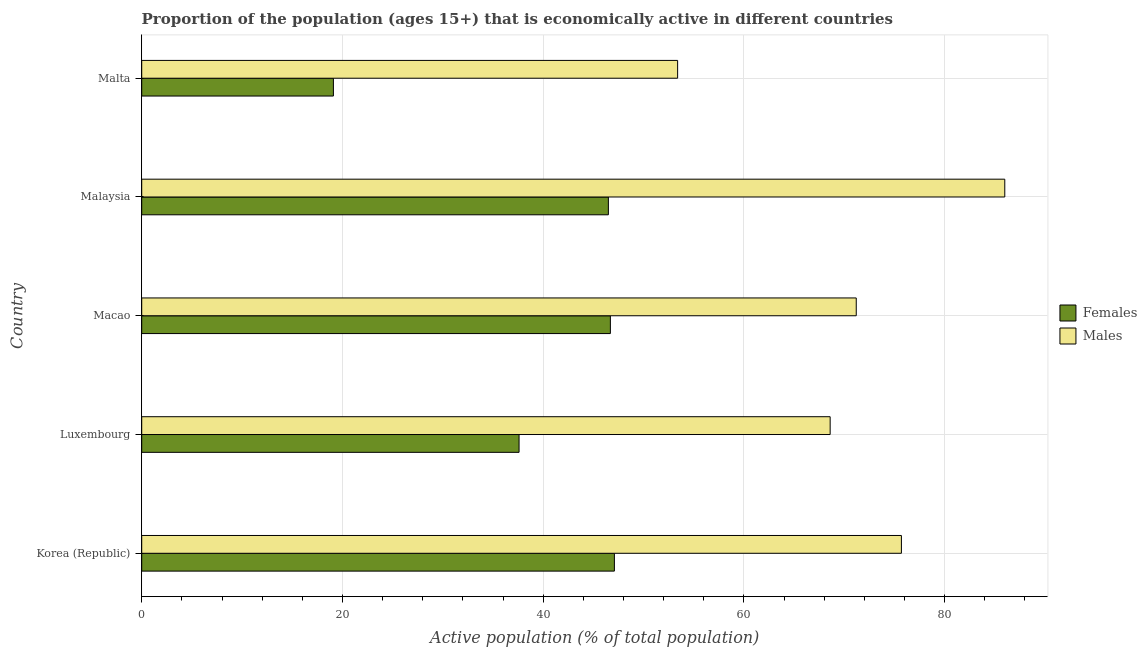Are the number of bars per tick equal to the number of legend labels?
Keep it short and to the point. Yes. How many bars are there on the 1st tick from the top?
Provide a short and direct response. 2. What is the label of the 3rd group of bars from the top?
Ensure brevity in your answer.  Macao. What is the percentage of economically active female population in Luxembourg?
Give a very brief answer. 37.6. Across all countries, what is the maximum percentage of economically active male population?
Offer a very short reply. 86. Across all countries, what is the minimum percentage of economically active female population?
Ensure brevity in your answer.  19.1. In which country was the percentage of economically active male population maximum?
Make the answer very short. Malaysia. In which country was the percentage of economically active male population minimum?
Your response must be concise. Malta. What is the total percentage of economically active male population in the graph?
Your answer should be compact. 354.9. What is the difference between the percentage of economically active female population in Malaysia and that in Malta?
Give a very brief answer. 27.4. What is the difference between the percentage of economically active male population in Malaysia and the percentage of economically active female population in Korea (Republic)?
Offer a very short reply. 38.9. What is the average percentage of economically active male population per country?
Offer a very short reply. 70.98. What is the difference between the percentage of economically active female population and percentage of economically active male population in Malta?
Your response must be concise. -34.3. In how many countries, is the percentage of economically active male population greater than 24 %?
Give a very brief answer. 5. What is the ratio of the percentage of economically active male population in Korea (Republic) to that in Luxembourg?
Offer a terse response. 1.1. What does the 2nd bar from the top in Luxembourg represents?
Offer a very short reply. Females. What does the 2nd bar from the bottom in Malta represents?
Ensure brevity in your answer.  Males. Are the values on the major ticks of X-axis written in scientific E-notation?
Offer a very short reply. No. How are the legend labels stacked?
Keep it short and to the point. Vertical. What is the title of the graph?
Your answer should be compact. Proportion of the population (ages 15+) that is economically active in different countries. Does "Quasi money growth" appear as one of the legend labels in the graph?
Make the answer very short. No. What is the label or title of the X-axis?
Offer a terse response. Active population (% of total population). What is the Active population (% of total population) in Females in Korea (Republic)?
Keep it short and to the point. 47.1. What is the Active population (% of total population) of Males in Korea (Republic)?
Provide a succinct answer. 75.7. What is the Active population (% of total population) in Females in Luxembourg?
Offer a very short reply. 37.6. What is the Active population (% of total population) of Males in Luxembourg?
Offer a very short reply. 68.6. What is the Active population (% of total population) in Females in Macao?
Keep it short and to the point. 46.7. What is the Active population (% of total population) of Males in Macao?
Provide a succinct answer. 71.2. What is the Active population (% of total population) of Females in Malaysia?
Your response must be concise. 46.5. What is the Active population (% of total population) of Males in Malaysia?
Provide a succinct answer. 86. What is the Active population (% of total population) in Females in Malta?
Ensure brevity in your answer.  19.1. What is the Active population (% of total population) in Males in Malta?
Offer a terse response. 53.4. Across all countries, what is the maximum Active population (% of total population) in Females?
Your answer should be very brief. 47.1. Across all countries, what is the minimum Active population (% of total population) of Females?
Your answer should be very brief. 19.1. Across all countries, what is the minimum Active population (% of total population) of Males?
Make the answer very short. 53.4. What is the total Active population (% of total population) in Females in the graph?
Your answer should be very brief. 197. What is the total Active population (% of total population) in Males in the graph?
Your response must be concise. 354.9. What is the difference between the Active population (% of total population) in Females in Korea (Republic) and that in Luxembourg?
Your response must be concise. 9.5. What is the difference between the Active population (% of total population) in Females in Korea (Republic) and that in Macao?
Give a very brief answer. 0.4. What is the difference between the Active population (% of total population) in Males in Korea (Republic) and that in Macao?
Provide a succinct answer. 4.5. What is the difference between the Active population (% of total population) of Females in Korea (Republic) and that in Malaysia?
Offer a very short reply. 0.6. What is the difference between the Active population (% of total population) in Females in Korea (Republic) and that in Malta?
Your answer should be very brief. 28. What is the difference between the Active population (% of total population) of Males in Korea (Republic) and that in Malta?
Ensure brevity in your answer.  22.3. What is the difference between the Active population (% of total population) of Females in Luxembourg and that in Macao?
Your answer should be very brief. -9.1. What is the difference between the Active population (% of total population) of Females in Luxembourg and that in Malaysia?
Offer a very short reply. -8.9. What is the difference between the Active population (% of total population) in Males in Luxembourg and that in Malaysia?
Offer a very short reply. -17.4. What is the difference between the Active population (% of total population) of Females in Luxembourg and that in Malta?
Your response must be concise. 18.5. What is the difference between the Active population (% of total population) in Males in Macao and that in Malaysia?
Give a very brief answer. -14.8. What is the difference between the Active population (% of total population) of Females in Macao and that in Malta?
Give a very brief answer. 27.6. What is the difference between the Active population (% of total population) in Males in Macao and that in Malta?
Offer a terse response. 17.8. What is the difference between the Active population (% of total population) of Females in Malaysia and that in Malta?
Ensure brevity in your answer.  27.4. What is the difference between the Active population (% of total population) in Males in Malaysia and that in Malta?
Your answer should be very brief. 32.6. What is the difference between the Active population (% of total population) in Females in Korea (Republic) and the Active population (% of total population) in Males in Luxembourg?
Make the answer very short. -21.5. What is the difference between the Active population (% of total population) of Females in Korea (Republic) and the Active population (% of total population) of Males in Macao?
Your response must be concise. -24.1. What is the difference between the Active population (% of total population) in Females in Korea (Republic) and the Active population (% of total population) in Males in Malaysia?
Ensure brevity in your answer.  -38.9. What is the difference between the Active population (% of total population) of Females in Korea (Republic) and the Active population (% of total population) of Males in Malta?
Provide a short and direct response. -6.3. What is the difference between the Active population (% of total population) of Females in Luxembourg and the Active population (% of total population) of Males in Macao?
Offer a terse response. -33.6. What is the difference between the Active population (% of total population) of Females in Luxembourg and the Active population (% of total population) of Males in Malaysia?
Your answer should be compact. -48.4. What is the difference between the Active population (% of total population) in Females in Luxembourg and the Active population (% of total population) in Males in Malta?
Provide a succinct answer. -15.8. What is the difference between the Active population (% of total population) of Females in Macao and the Active population (% of total population) of Males in Malaysia?
Your answer should be very brief. -39.3. What is the difference between the Active population (% of total population) in Females in Macao and the Active population (% of total population) in Males in Malta?
Offer a very short reply. -6.7. What is the difference between the Active population (% of total population) in Females in Malaysia and the Active population (% of total population) in Males in Malta?
Make the answer very short. -6.9. What is the average Active population (% of total population) in Females per country?
Give a very brief answer. 39.4. What is the average Active population (% of total population) in Males per country?
Keep it short and to the point. 70.98. What is the difference between the Active population (% of total population) in Females and Active population (% of total population) in Males in Korea (Republic)?
Make the answer very short. -28.6. What is the difference between the Active population (% of total population) of Females and Active population (% of total population) of Males in Luxembourg?
Give a very brief answer. -31. What is the difference between the Active population (% of total population) of Females and Active population (% of total population) of Males in Macao?
Offer a very short reply. -24.5. What is the difference between the Active population (% of total population) of Females and Active population (% of total population) of Males in Malaysia?
Your answer should be very brief. -39.5. What is the difference between the Active population (% of total population) in Females and Active population (% of total population) in Males in Malta?
Provide a short and direct response. -34.3. What is the ratio of the Active population (% of total population) of Females in Korea (Republic) to that in Luxembourg?
Ensure brevity in your answer.  1.25. What is the ratio of the Active population (% of total population) in Males in Korea (Republic) to that in Luxembourg?
Give a very brief answer. 1.1. What is the ratio of the Active population (% of total population) of Females in Korea (Republic) to that in Macao?
Your answer should be compact. 1.01. What is the ratio of the Active population (% of total population) of Males in Korea (Republic) to that in Macao?
Offer a very short reply. 1.06. What is the ratio of the Active population (% of total population) of Females in Korea (Republic) to that in Malaysia?
Give a very brief answer. 1.01. What is the ratio of the Active population (% of total population) of Males in Korea (Republic) to that in Malaysia?
Ensure brevity in your answer.  0.88. What is the ratio of the Active population (% of total population) of Females in Korea (Republic) to that in Malta?
Your answer should be compact. 2.47. What is the ratio of the Active population (% of total population) of Males in Korea (Republic) to that in Malta?
Make the answer very short. 1.42. What is the ratio of the Active population (% of total population) of Females in Luxembourg to that in Macao?
Keep it short and to the point. 0.81. What is the ratio of the Active population (% of total population) of Males in Luxembourg to that in Macao?
Offer a very short reply. 0.96. What is the ratio of the Active population (% of total population) of Females in Luxembourg to that in Malaysia?
Offer a terse response. 0.81. What is the ratio of the Active population (% of total population) in Males in Luxembourg to that in Malaysia?
Your answer should be compact. 0.8. What is the ratio of the Active population (% of total population) of Females in Luxembourg to that in Malta?
Give a very brief answer. 1.97. What is the ratio of the Active population (% of total population) of Males in Luxembourg to that in Malta?
Keep it short and to the point. 1.28. What is the ratio of the Active population (% of total population) in Females in Macao to that in Malaysia?
Ensure brevity in your answer.  1. What is the ratio of the Active population (% of total population) of Males in Macao to that in Malaysia?
Your answer should be very brief. 0.83. What is the ratio of the Active population (% of total population) of Females in Macao to that in Malta?
Give a very brief answer. 2.44. What is the ratio of the Active population (% of total population) of Males in Macao to that in Malta?
Make the answer very short. 1.33. What is the ratio of the Active population (% of total population) of Females in Malaysia to that in Malta?
Your answer should be very brief. 2.43. What is the ratio of the Active population (% of total population) in Males in Malaysia to that in Malta?
Offer a terse response. 1.61. What is the difference between the highest and the second highest Active population (% of total population) in Males?
Keep it short and to the point. 10.3. What is the difference between the highest and the lowest Active population (% of total population) in Males?
Offer a very short reply. 32.6. 